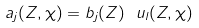<formula> <loc_0><loc_0><loc_500><loc_500>a _ { j } ( Z , \chi ) = b _ { j } ( Z ) \ u _ { l } ( Z , \chi )</formula> 